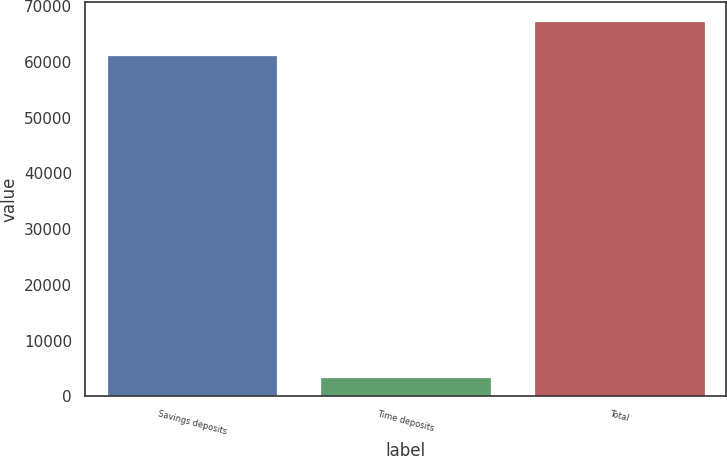Convert chart. <chart><loc_0><loc_0><loc_500><loc_500><bar_chart><fcel>Savings deposits<fcel>Time deposits<fcel>Total<nl><fcel>61258<fcel>3392<fcel>67383.8<nl></chart> 